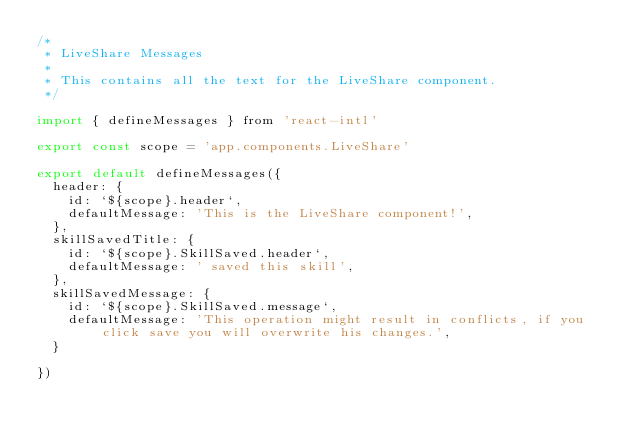Convert code to text. <code><loc_0><loc_0><loc_500><loc_500><_JavaScript_>/*
 * LiveShare Messages
 *
 * This contains all the text for the LiveShare component.
 */

import { defineMessages } from 'react-intl'

export const scope = 'app.components.LiveShare'

export default defineMessages({
  header: {
    id: `${scope}.header`,
    defaultMessage: 'This is the LiveShare component!',
  },
  skillSavedTitle: {
    id: `${scope}.SkillSaved.header`,
    defaultMessage: ' saved this skill',
  },
  skillSavedMessage: {
    id: `${scope}.SkillSaved.message`,
    defaultMessage: 'This operation might result in conflicts, if you click save you will overwrite his changes.',
  }

})
</code> 